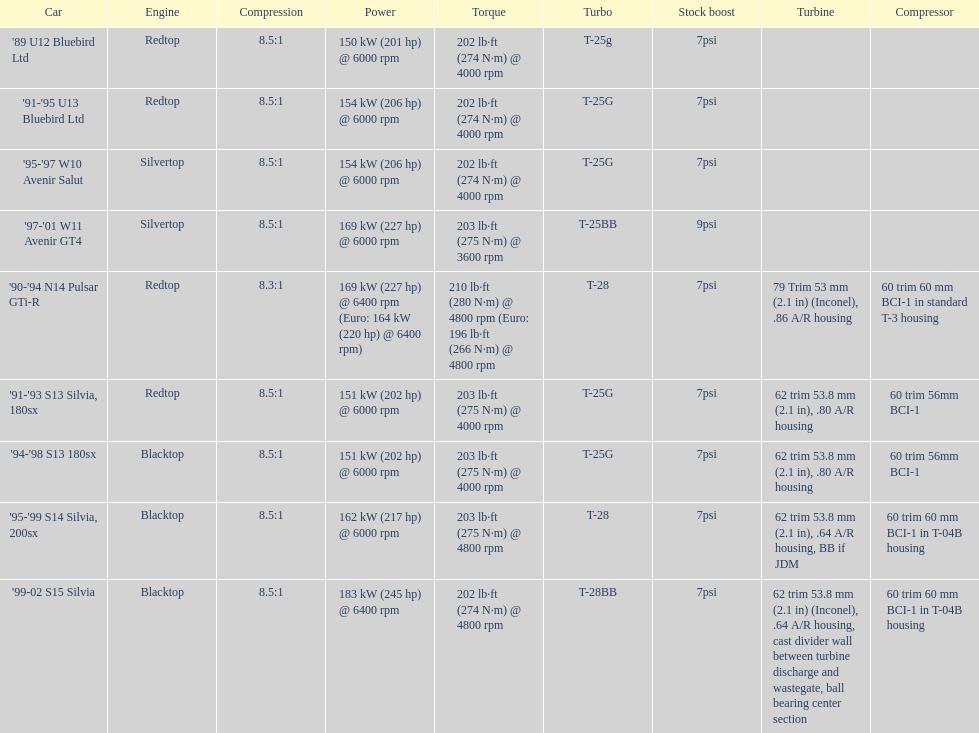Which vehicle is the sole one possessing over 230 horsepower? '99-02 S15 Silvia. Could you parse the entire table? {'header': ['Car', 'Engine', 'Compression', 'Power', 'Torque', 'Turbo', 'Stock boost', 'Turbine', 'Compressor'], 'rows': [["'89 U12 Bluebird Ltd", 'Redtop', '8.5:1', '150\xa0kW (201\xa0hp) @ 6000 rpm', '202\xa0lb·ft (274\xa0N·m) @ 4000 rpm', 'T-25g', '7psi', '', ''], ["'91-'95 U13 Bluebird Ltd", 'Redtop', '8.5:1', '154\xa0kW (206\xa0hp) @ 6000 rpm', '202\xa0lb·ft (274\xa0N·m) @ 4000 rpm', 'T-25G', '7psi', '', ''], ["'95-'97 W10 Avenir Salut", 'Silvertop', '8.5:1', '154\xa0kW (206\xa0hp) @ 6000 rpm', '202\xa0lb·ft (274\xa0N·m) @ 4000 rpm', 'T-25G', '7psi', '', ''], ["'97-'01 W11 Avenir GT4", 'Silvertop', '8.5:1', '169\xa0kW (227\xa0hp) @ 6000 rpm', '203\xa0lb·ft (275\xa0N·m) @ 3600 rpm', 'T-25BB', '9psi', '', ''], ["'90-'94 N14 Pulsar GTi-R", 'Redtop', '8.3:1', '169\xa0kW (227\xa0hp) @ 6400 rpm (Euro: 164\xa0kW (220\xa0hp) @ 6400 rpm)', '210\xa0lb·ft (280\xa0N·m) @ 4800 rpm (Euro: 196\xa0lb·ft (266\xa0N·m) @ 4800 rpm', 'T-28', '7psi', '79 Trim 53\xa0mm (2.1\xa0in) (Inconel), .86 A/R housing', '60 trim 60\xa0mm BCI-1 in standard T-3 housing'], ["'91-'93 S13 Silvia, 180sx", 'Redtop', '8.5:1', '151\xa0kW (202\xa0hp) @ 6000 rpm', '203\xa0lb·ft (275\xa0N·m) @ 4000 rpm', 'T-25G', '7psi', '62 trim 53.8\xa0mm (2.1\xa0in), .80 A/R housing', '60 trim 56mm BCI-1'], ["'94-'98 S13 180sx", 'Blacktop', '8.5:1', '151\xa0kW (202\xa0hp) @ 6000 rpm', '203\xa0lb·ft (275\xa0N·m) @ 4000 rpm', 'T-25G', '7psi', '62 trim 53.8\xa0mm (2.1\xa0in), .80 A/R housing', '60 trim 56mm BCI-1'], ["'95-'99 S14 Silvia, 200sx", 'Blacktop', '8.5:1', '162\xa0kW (217\xa0hp) @ 6000 rpm', '203\xa0lb·ft (275\xa0N·m) @ 4800 rpm', 'T-28', '7psi', '62 trim 53.8\xa0mm (2.1\xa0in), .64 A/R housing, BB if JDM', '60 trim 60\xa0mm BCI-1 in T-04B housing'], ["'99-02 S15 Silvia", 'Blacktop', '8.5:1', '183\xa0kW (245\xa0hp) @ 6400 rpm', '202\xa0lb·ft (274\xa0N·m) @ 4800 rpm', 'T-28BB', '7psi', '62 trim 53.8\xa0mm (2.1\xa0in) (Inconel), .64 A/R housing, cast divider wall between turbine discharge and wastegate, ball bearing center section', '60 trim 60\xa0mm BCI-1 in T-04B housing']]} 